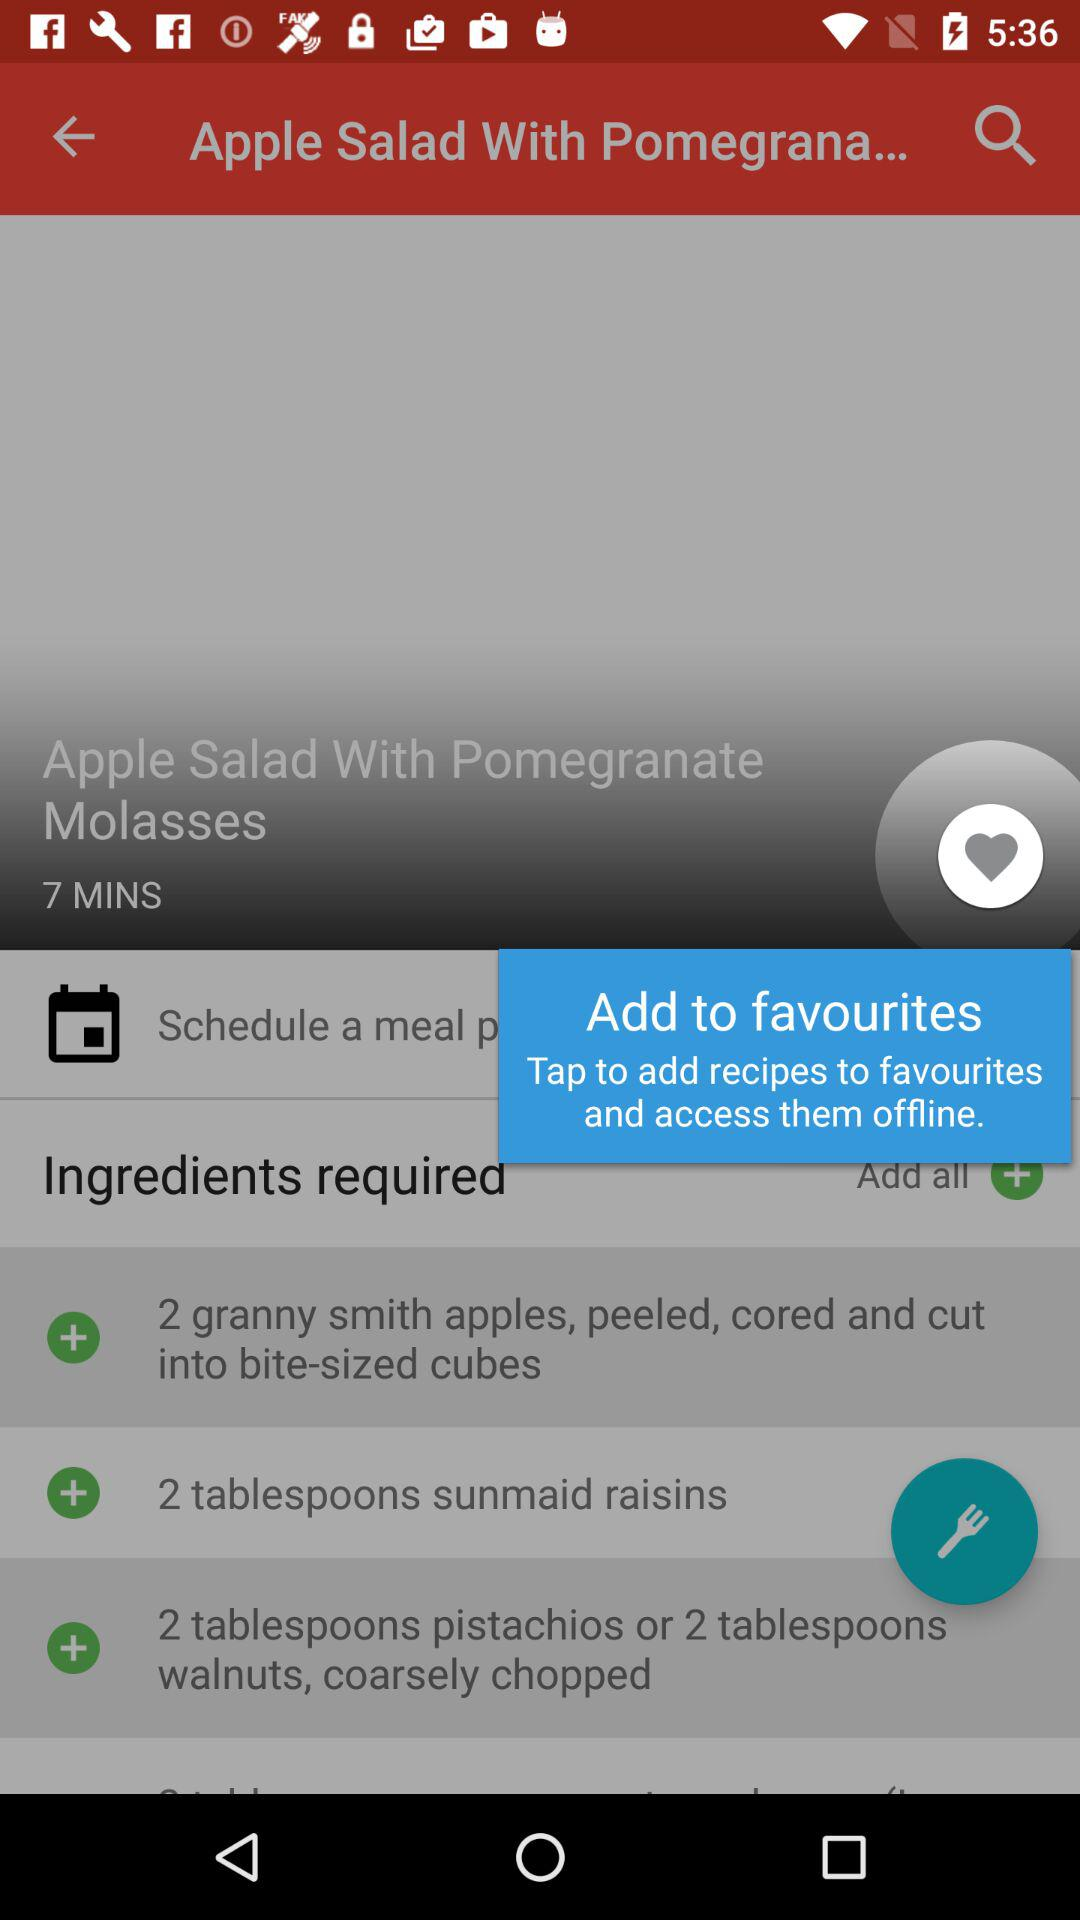How many Granny Smith apples are required? There are 2 Granny Smith apples required. 